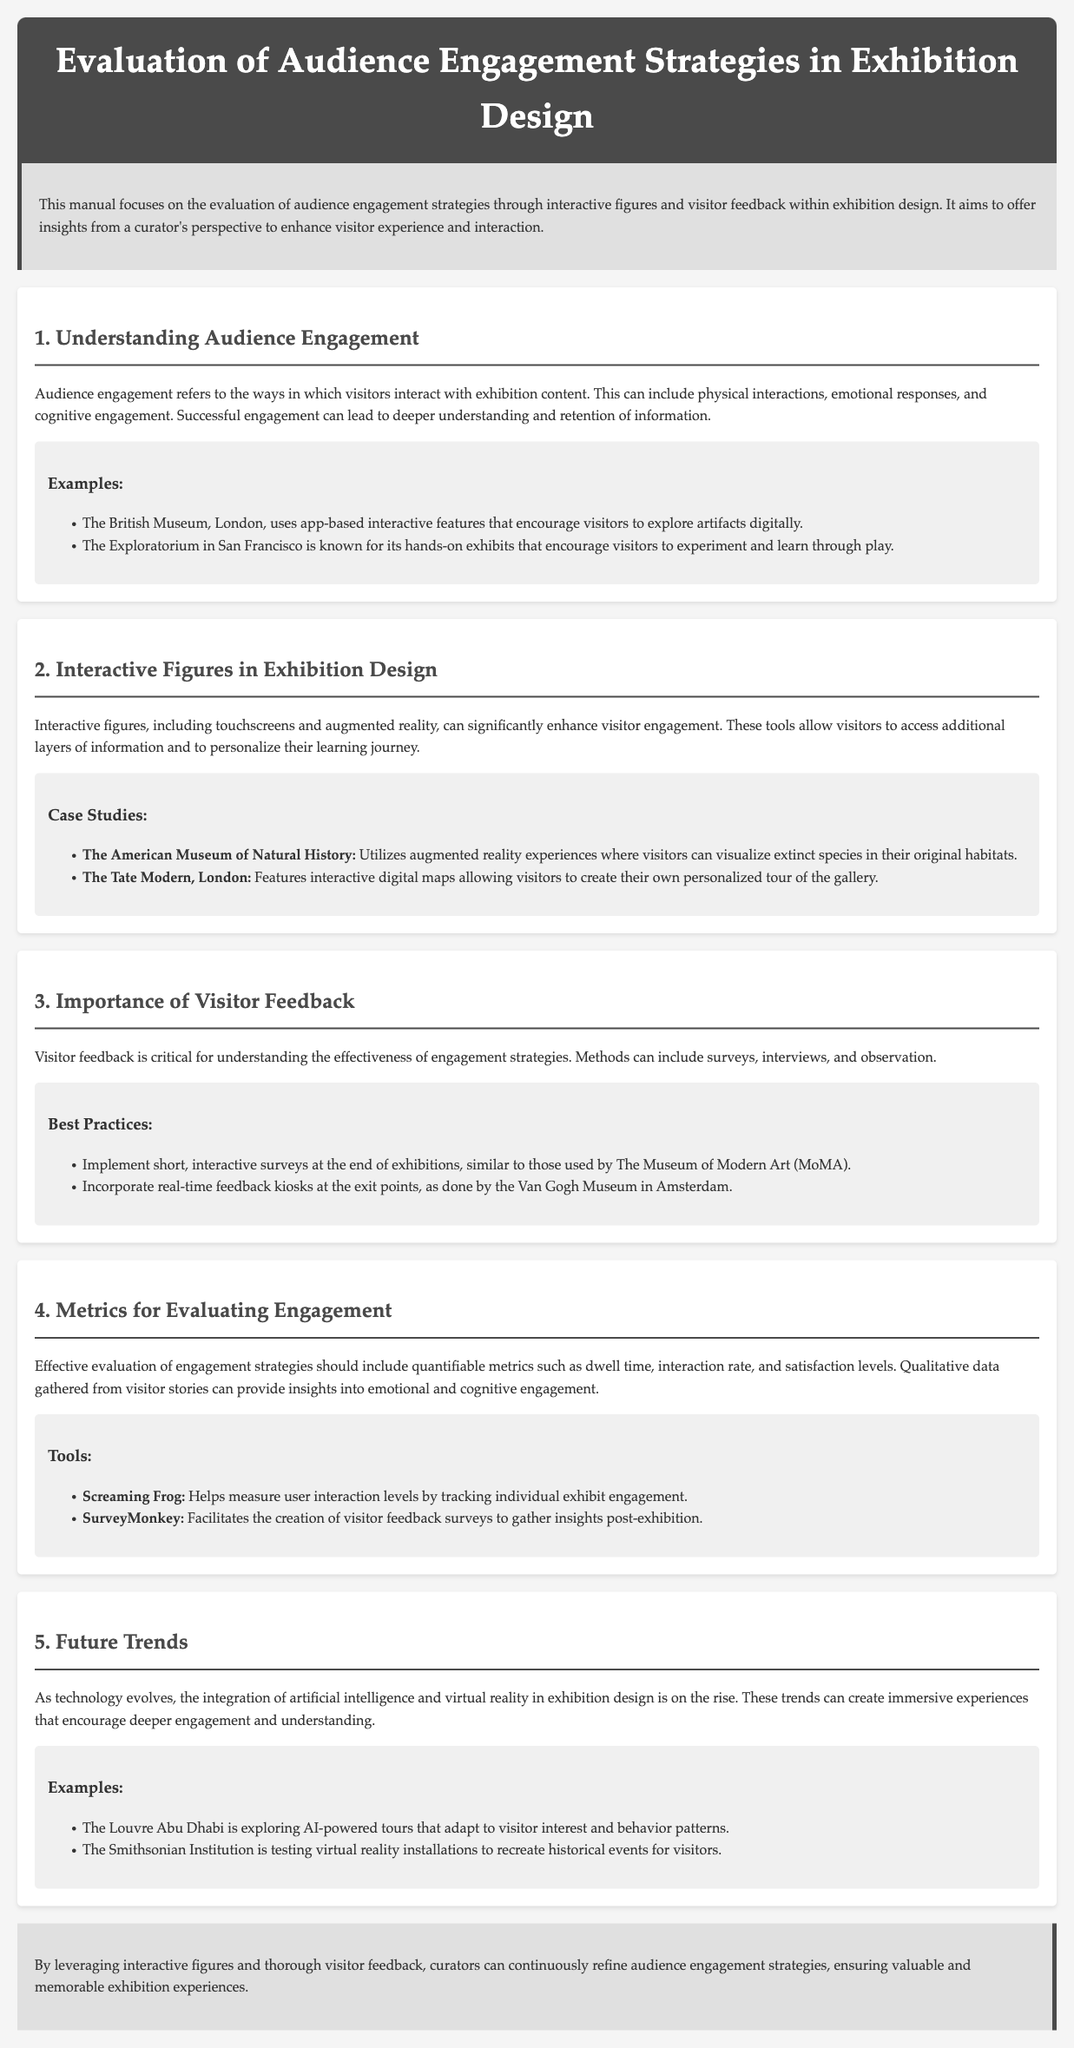What is the main focus of the manual? The manual focuses on the evaluation of audience engagement strategies in exhibition design.
Answer: Evaluation of audience engagement strategies in exhibition design Which museum uses app-based interactive features? The British Museum in London employs app-based interactive features for visitor engagement.
Answer: The British Museum What tools are used to evaluate user interaction levels? The tool mentioned for measuring user interaction levels is Screaming Frog.
Answer: Screaming Frog What method does The Museum of Modern Art (MoMA) use for feedback? MoMA implements short, interactive surveys at the end of exhibitions.
Answer: Short, interactive surveys Which technology trends are mentioned for future exhibition design? The trends mentioned include artificial intelligence and virtual reality.
Answer: Artificial intelligence and virtual reality How does visitor feedback help in exhibition design? Visitor feedback is critical for understanding the effectiveness of engagement strategies.
Answer: Understanding the effectiveness of engagement strategies What kind of experience does The American Museum of Natural History offer? It offers augmented reality experiences to visualize extinct species.
Answer: Augmented reality experiences Which exhibit is known for hands-on engagement? The Exploratorium in San Francisco is known for its hands-on exhibits.
Answer: The Exploratorium 